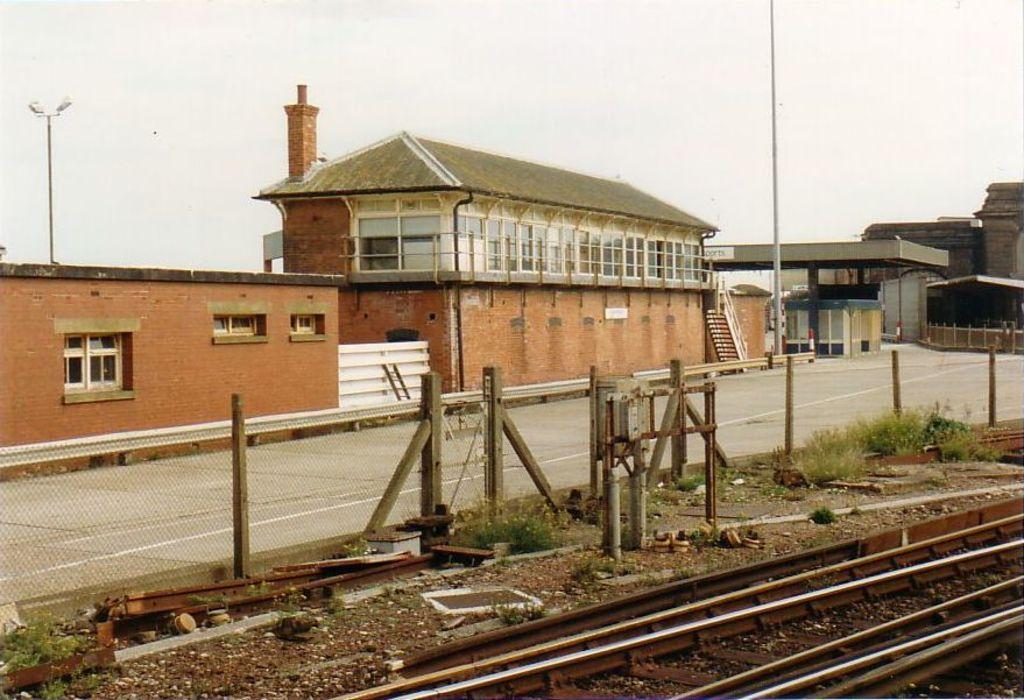In one or two sentences, can you explain what this image depicts? In this image we can see buildings, staircase, mesh, shrubs, ground, railway track, poles, street lights, chimney and sky. 